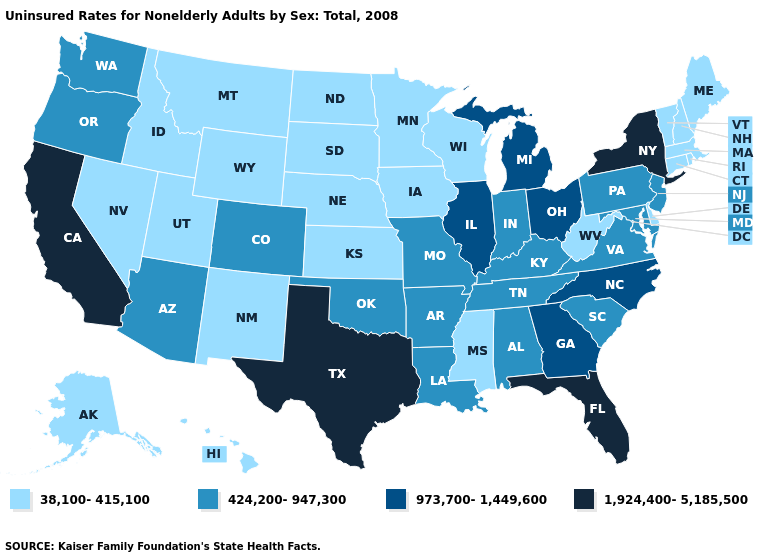Among the states that border Arizona , does Colorado have the highest value?
Be succinct. No. What is the lowest value in the USA?
Give a very brief answer. 38,100-415,100. Does South Carolina have the lowest value in the USA?
Concise answer only. No. What is the lowest value in states that border Kansas?
Give a very brief answer. 38,100-415,100. What is the value of Nebraska?
Quick response, please. 38,100-415,100. Does North Dakota have the highest value in the MidWest?
Write a very short answer. No. What is the value of Kentucky?
Quick response, please. 424,200-947,300. Among the states that border Florida , which have the highest value?
Concise answer only. Georgia. What is the highest value in states that border Nebraska?
Concise answer only. 424,200-947,300. How many symbols are there in the legend?
Give a very brief answer. 4. What is the value of Indiana?
Answer briefly. 424,200-947,300. What is the highest value in the USA?
Short answer required. 1,924,400-5,185,500. What is the value of Massachusetts?
Keep it brief. 38,100-415,100. Name the states that have a value in the range 973,700-1,449,600?
Short answer required. Georgia, Illinois, Michigan, North Carolina, Ohio. Does Massachusetts have the lowest value in the Northeast?
Keep it brief. Yes. 